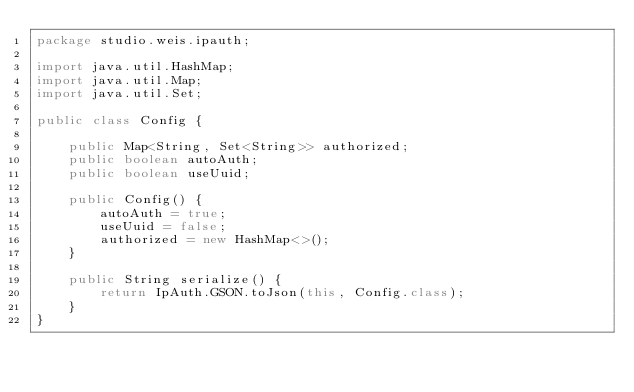<code> <loc_0><loc_0><loc_500><loc_500><_Java_>package studio.weis.ipauth;

import java.util.HashMap;
import java.util.Map;
import java.util.Set;

public class Config {

    public Map<String, Set<String>> authorized;
    public boolean autoAuth;
    public boolean useUuid;

    public Config() {
        autoAuth = true;
        useUuid = false;
        authorized = new HashMap<>();
    }

    public String serialize() {
        return IpAuth.GSON.toJson(this, Config.class);
    }
}
</code> 